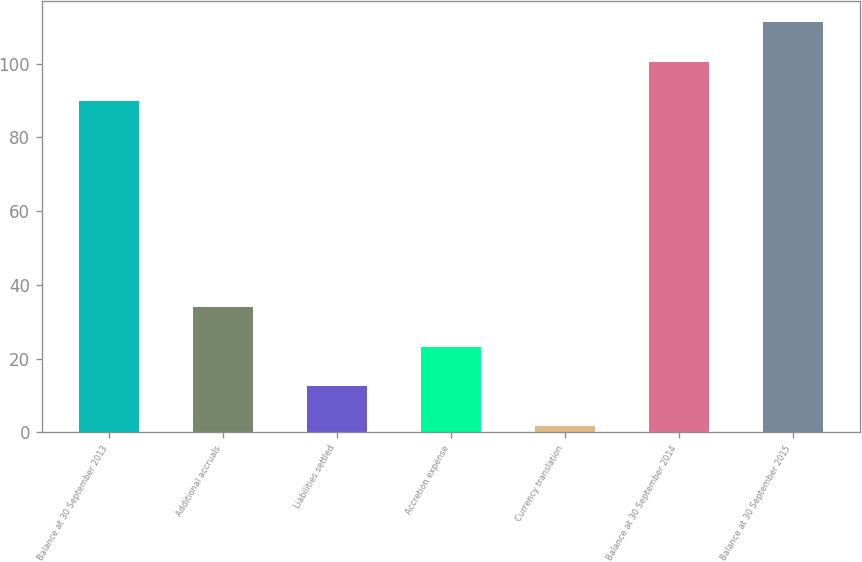Convert chart. <chart><loc_0><loc_0><loc_500><loc_500><bar_chart><fcel>Balance at 30 September 2013<fcel>Additional accruals<fcel>Liabilities settled<fcel>Accretion expense<fcel>Currency translation<fcel>Balance at 30 September 2014<fcel>Balance at 30 September 2015<nl><fcel>89.8<fcel>34.01<fcel>12.47<fcel>23.24<fcel>1.7<fcel>100.57<fcel>111.34<nl></chart> 